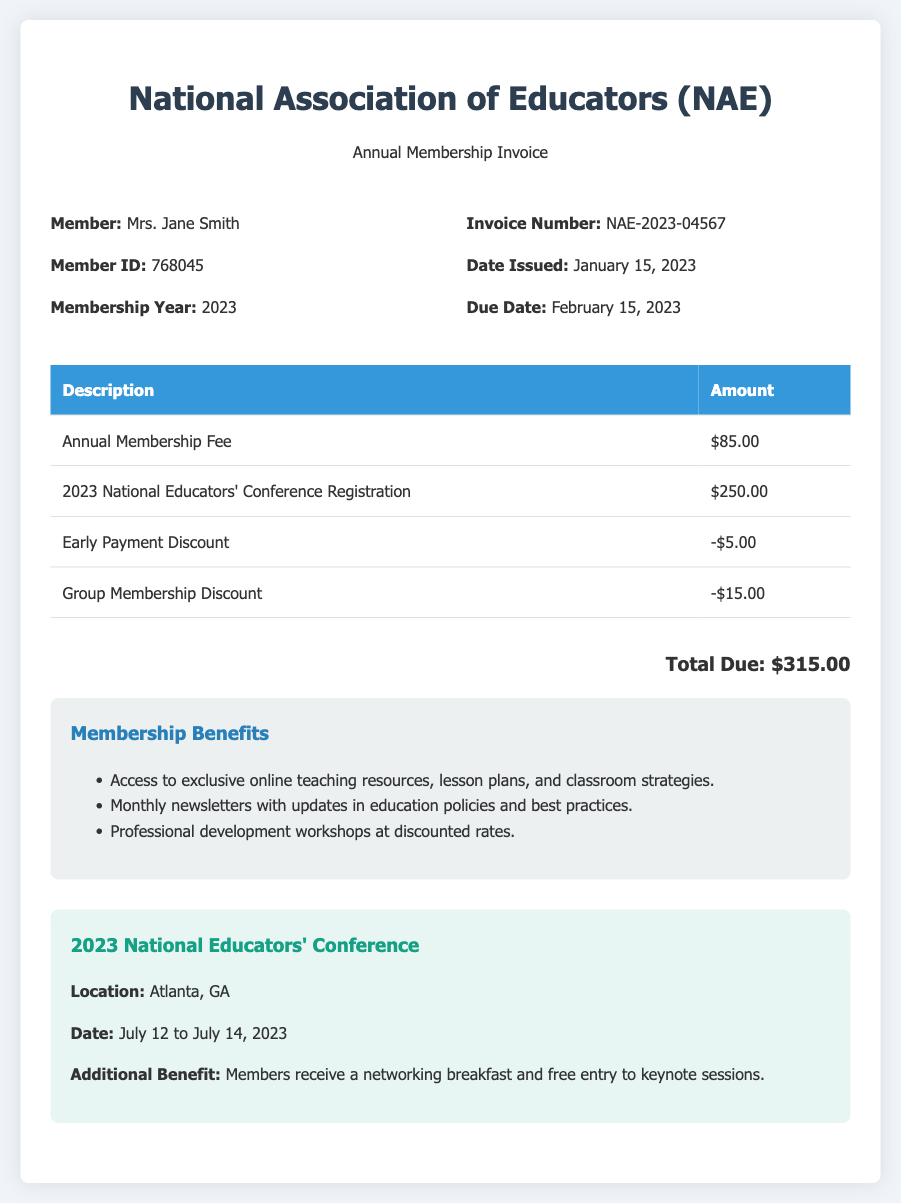What is the membership year? The membership year is specified in the document, indicating the period for which the membership is valid.
Answer: 2023 What is the total due amount? The total due amount is calculated based on the costs and discounts listed in the invoice table.
Answer: $315.00 Who is the member listed on the invoice? The member name is provided at the top of the invoice under the member details section.
Answer: Mrs. Jane Smith What is the invoice number? The invoice number is a unique identifier for this transaction, found in the invoice details section.
Answer: NAE-2023-04567 What is the amount of the annual membership fee? The annual membership fee is stated in the invoice table, as one of the primary charges.
Answer: $85.00 Where is the conference being held? The location of the conference is mentioned in the section dedicated to the 2023 National Educators' Conference.
Answer: Atlanta, GA How much is the early payment discount? The early payment discount amount is provided in the discounts portion of the invoice table.
Answer: -$5.00 What is one benefit of membership? The benefits of membership are listed in a dedicated section; any of the listed benefits would suffice.
Answer: Access to exclusive online teaching resources What dates is the National Educators' Conference scheduled for? The dates for the conference are clearly specified in the relevant section of the document.
Answer: July 12 to July 14, 2023 